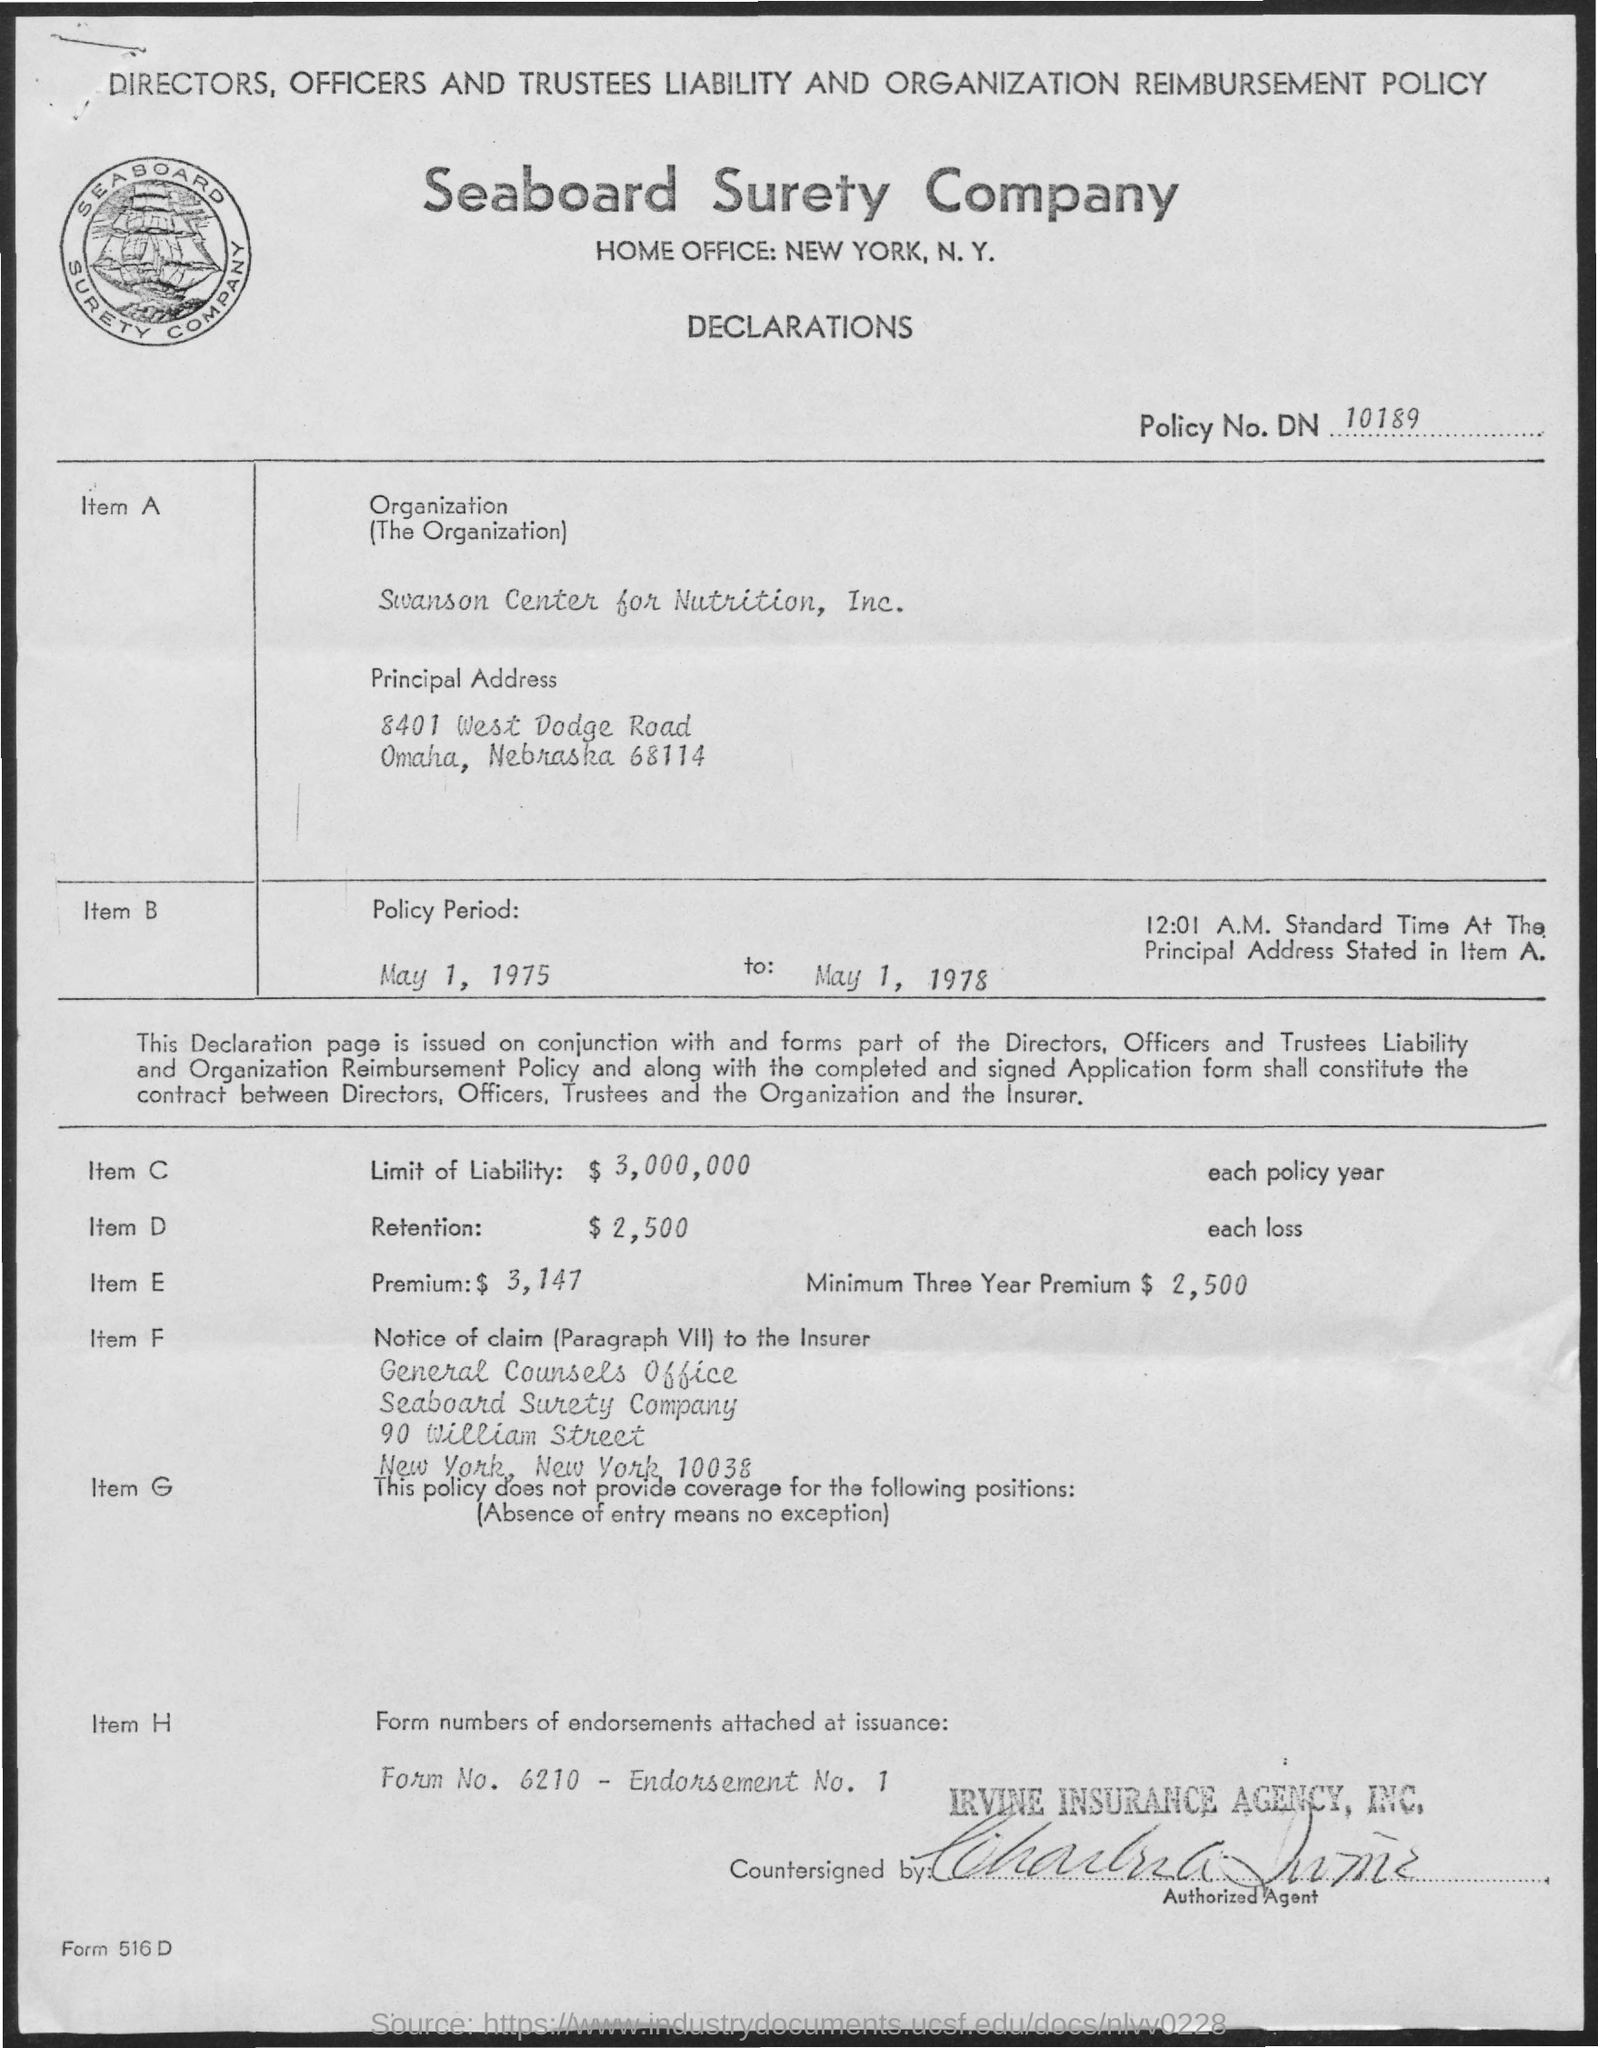Give some essential details in this illustration. The company mentioned is Seaboard Surety Company. The amount mentioned for the limit of liability for item C is $3,000,000. The premium amount mentioned for Item E is $3,147. The policy number mentioned is DN 10189. The minimum three-year premium for item E is $2,500. 